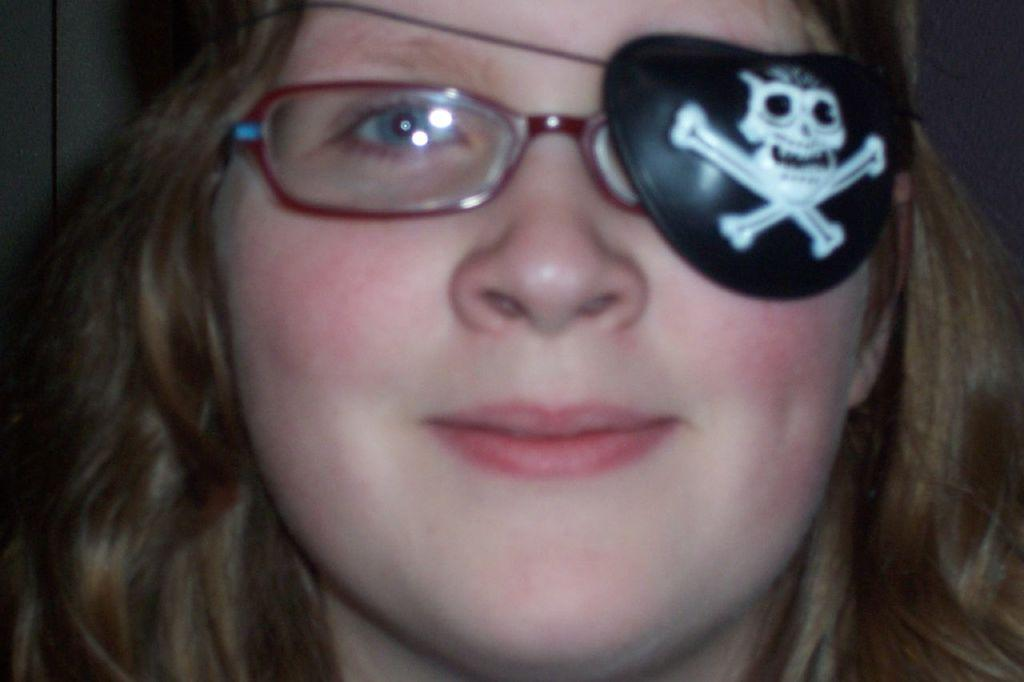Who is the main subject in the image? There is a woman in the image. What is the woman wearing on her face? The woman is wearing spectacles. Are there any unique features on the spectacles? Yes, the spectacles have a skull mask attached to the left eye. What type of industry is depicted in the background of the image? There is no industry depicted in the image; it only features the woman wearing spectacles with a skull mask. How much payment is required to remove the skull mask from the spectacles? There is no payment required to remove the skull mask from the spectacles, as it is a part of the spectacles' design. 